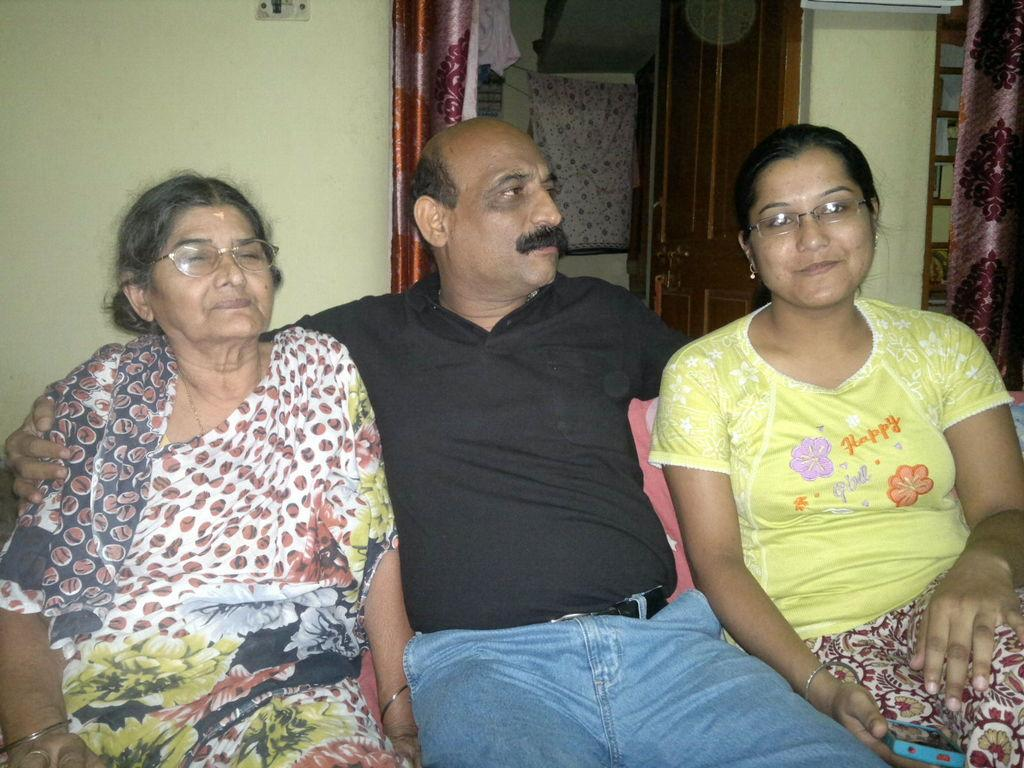How many people are in the image? There are three individuals in the image, a man and two women. What are the people in the image doing? All three individuals are sitting on a sofa. What is located behind the sofa? There is a wall behind the sofa. What architectural feature can be seen on the wall? There is a door on the wall. What type of window treatment is present in the image? Curtains are present in the image. How many fish can be seen swimming in the image? There are no fish present in the image. What type of neck accessory is the man wearing in the image? The man is not wearing any neck accessory in the image. 